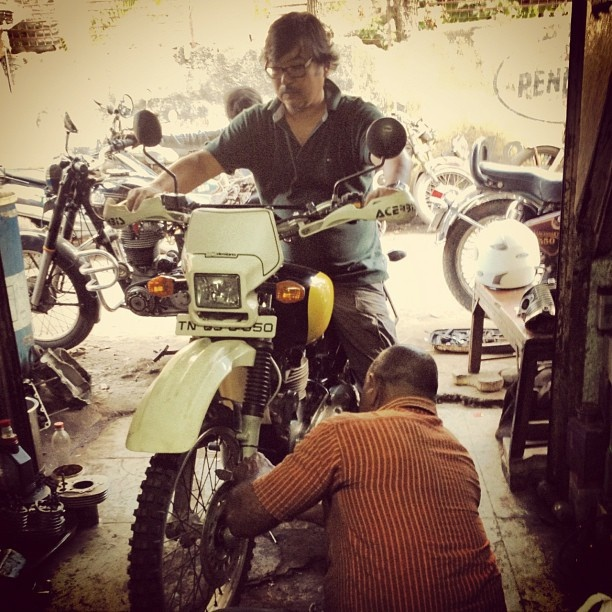Describe the objects in this image and their specific colors. I can see motorcycle in tan, black, and maroon tones, people in tan, maroon, brown, and black tones, people in tan, maroon, black, and gray tones, motorcycle in tan, maroon, beige, brown, and black tones, and motorcycle in tan, gray, and beige tones in this image. 